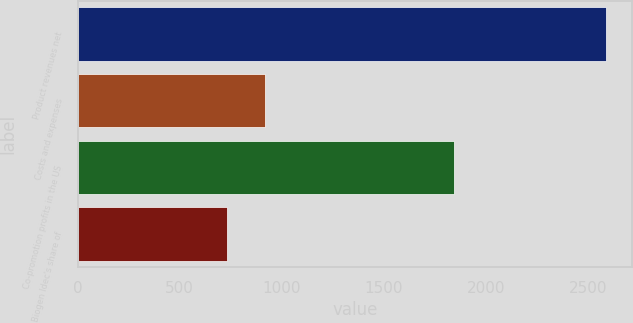Convert chart. <chart><loc_0><loc_0><loc_500><loc_500><bar_chart><fcel>Product revenues net<fcel>Costs and expenses<fcel>Co-promotion profits in the US<fcel>Biogen Idec's share of<nl><fcel>2587.4<fcel>918.89<fcel>1846.4<fcel>733.5<nl></chart> 